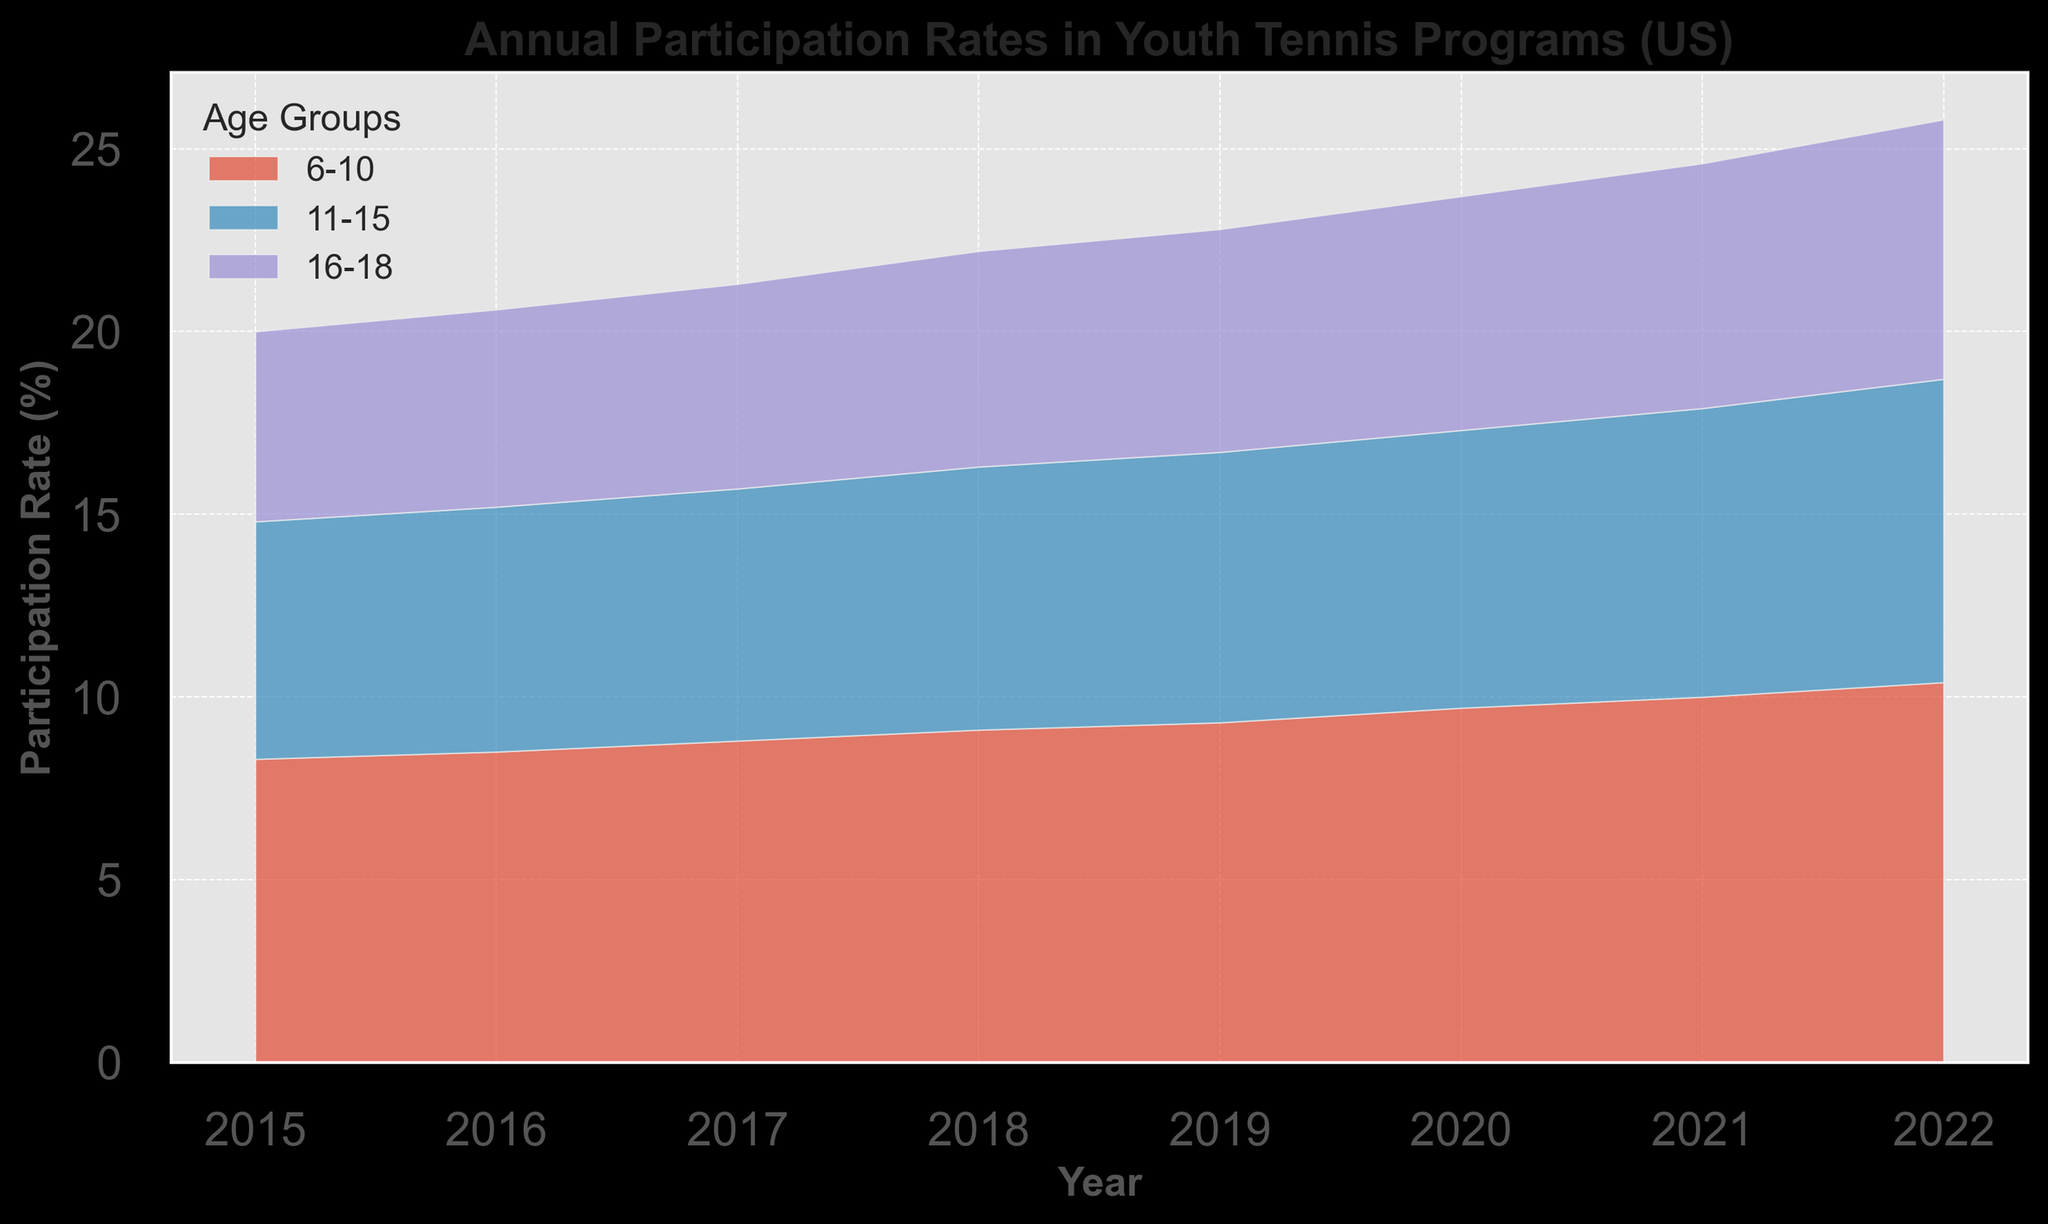Which age group had the highest participation rate in 2022? By looking at the height of the areas for each age group in 2022, the highest is represented by the age group 11-15.
Answer: 11-15 How much did the participation rate for the 6-10 age group increase from 2018 to 2022? In 2018, the participation rate for the 6-10 age group was 5.9%, and in 2022, it was 7.1%. The increase is 7.1% - 5.9% = 1.2%.
Answer: 1.2% In which year did the 16-18 age group have the lowest participation rate? By examining the height of the areas for the 16-18 age group across all years, the lowest value occurred in 2015.
Answer: 2015 What’s the combined participation rate for all age groups in 2021? Sum the participation rates for all three age groups in 2021: 6.7% (6-10) + 10.0% (11-15) + 7.9% (16-18) = 24.6%.
Answer: 24.6% How did the participation rate of the 11-15 age group change from 2015 to 2020? The participation rate in 2015 for the 11-15 age group was 8.3%, and in 2020 it was 9.7%. The change is 9.7% - 8.3% = 1.4%.
Answer: 1.4% Which age group showed the most consistent increase in participation rate over the years? By observing the general trend for each age group from 2015 to 2022, the 11-15 age group showed a consistent increase every year.
Answer: 11-15 What was the participation rate difference between the 6-10 and 16-18 age groups in 2017? The participation rate for the 6-10 age group in 2017 was 5.6%, and for the 16-18 age group, it was 6.9%. The difference is 6.9% - 5.6% = 1.3%.
Answer: 1.3% Which age group had the greatest increase in participation rate from 2016 to 2017? Comparing the participation rates from 2016 to 2017, the 11-15 age group increased from 8.5% to 8.8%, a difference of 0.3%. The 16-18 age group increased by 0.2% (6.7% to 6.9%), and the 6-10 age group increased by 0.2% (5.4% to 5.6%). Therefore, the 11-15 age group had the greatest increase.
Answer: 11-15 What was the total participation rate (sum) for all age groups in 2019? Sum the participation rates for all three age groups in 2019: 6.1% (6-10) + 9.3% (11-15) + 7.4% (16-18) = 22.8%.
Answer: 22.8% Which year showed the biggest year-on-year increase in the participation rate for the 6-10 age group? By comparing year-on-year changes for the 6-10 age group: 2015-2016 (0.2), 2016-2017 (0.2), 2017-2018 (0.3), 2018-2019 (0.2), 2019-2020 (0.3), 2020-2021 (0.3), 2021-2022 (0.4). The biggest increase was from 2021 to 2022 with 0.4%.
Answer: 2021-2022 